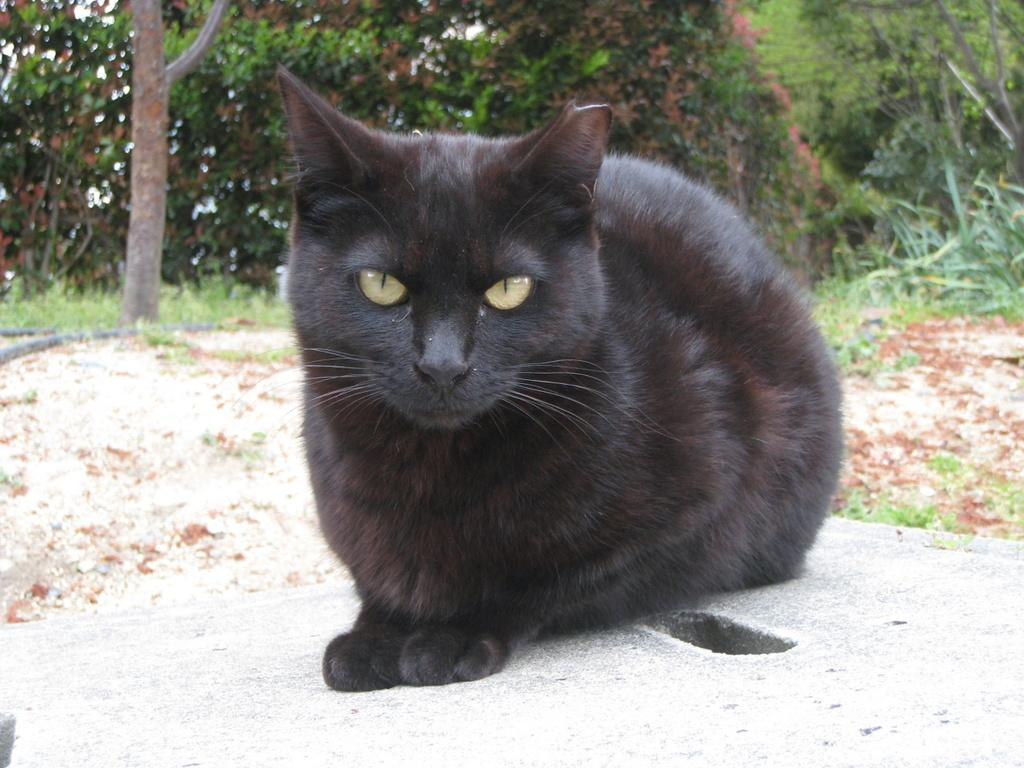What type of animal is in the picture? There is a black cat in the picture. Where is the cat located in the image? The cat is sitting on the floor. What can be seen in the background of the image? There are trees visible in the background of the image. What type of part or unit is visible in the image? There is no part or unit present in the image; it features a black cat sitting on the floor with trees visible in the background. 